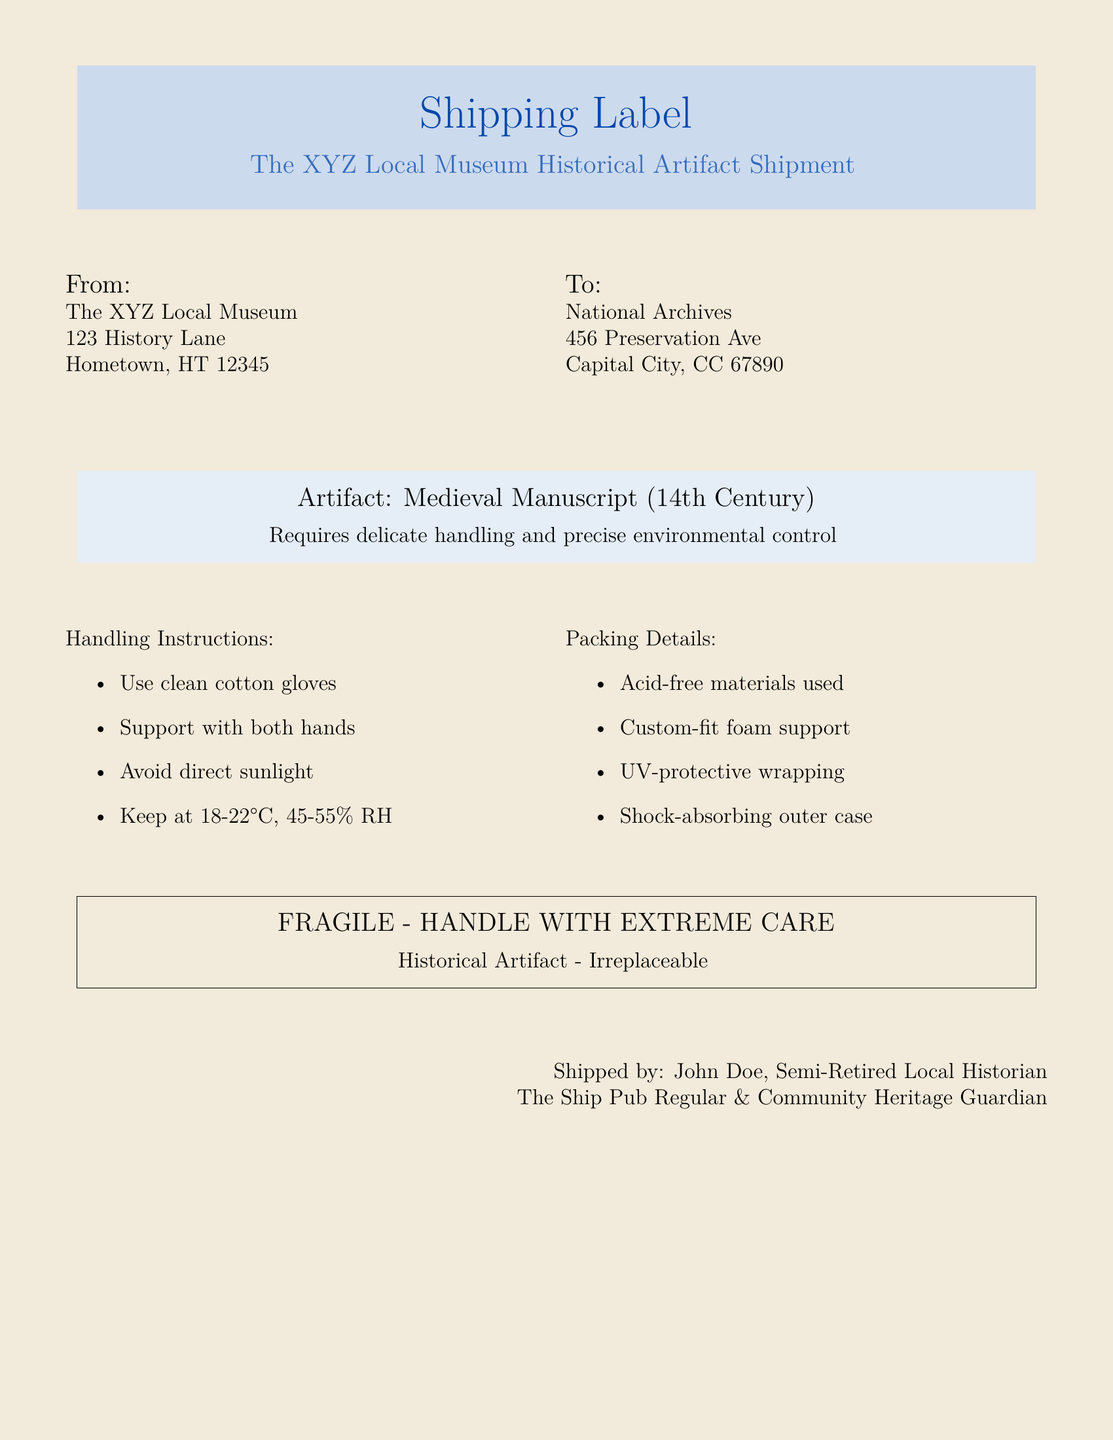What is the name of the artifact? The name of the artifact is specified in the document.
Answer: Medieval Manuscript (14th Century) What are the handling temperature limits? The handling temperature limits are given within the document.
Answer: 18-22°C Where is the shipment originating from? The originating address of the shipment is detailed in the document.
Answer: The XYZ Local Museum, 123 History Lane, Hometown, HT 12345 Who is the shipped by individual? The document states the name of the individual responsible for shipping.
Answer: John Doe What type of wrapping is used for the packing? The kind of material used for packing is mentioned in one of the lists.
Answer: UV-protective wrapping What is the humidity range specified? The humidity range is provided alongside the temperature instructions in the document.
Answer: 45-55% RH What color is used for the shipping label's background? The background color of the shipping label is described in the document.
Answer: Oldpaper How should the artifact be supported during handling? The instructions for handling specify how to support the artifact properly.
Answer: With both hands What type of gloves should be used for handling? The document lists specific requirements for handling instructions.
Answer: Clean cotton gloves 